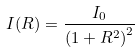<formula> <loc_0><loc_0><loc_500><loc_500>I ( R ) = \frac { I _ { 0 } } { \left ( 1 + R ^ { 2 } \right ) ^ { 2 } }</formula> 